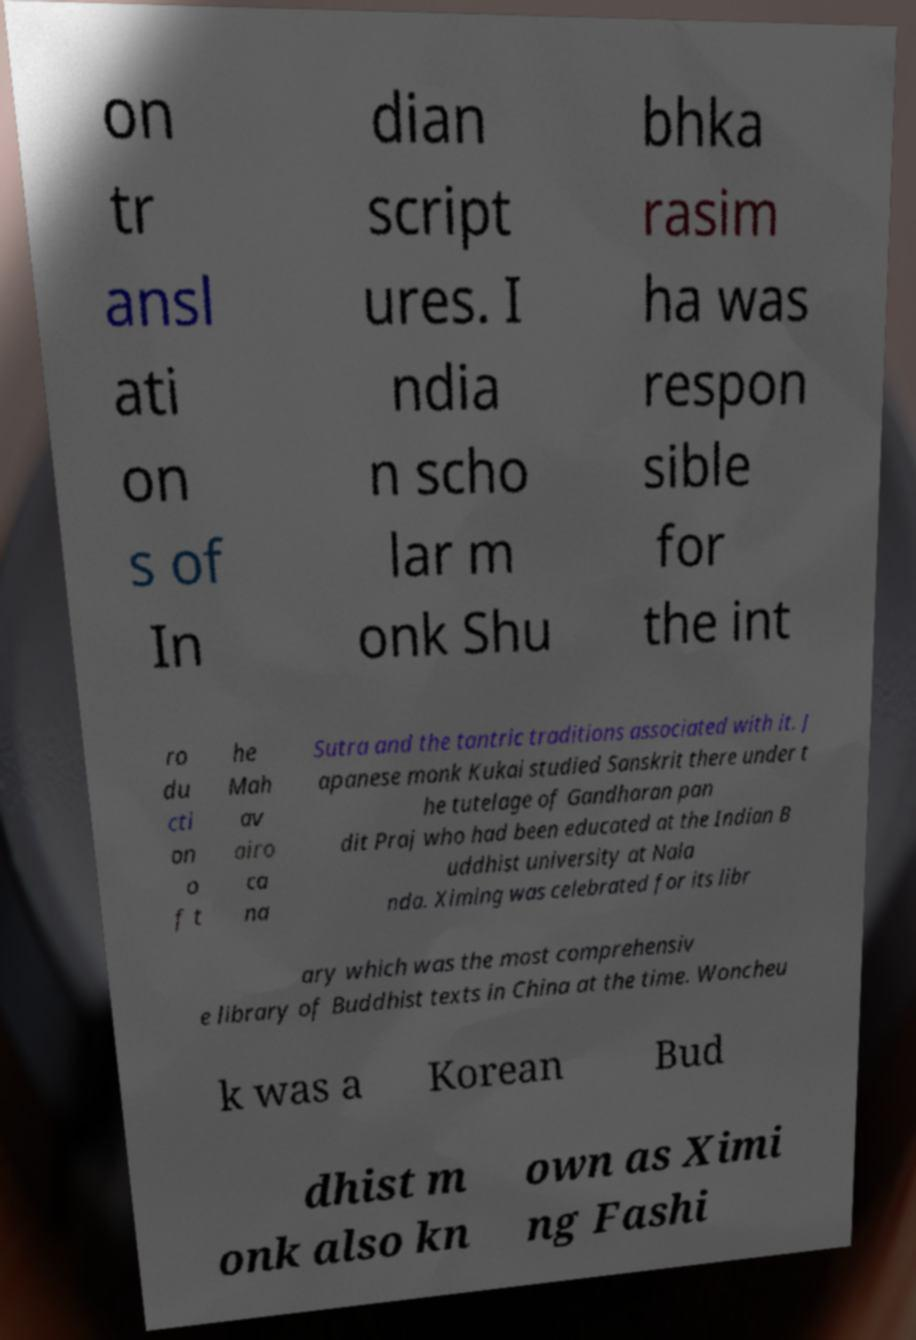What messages or text are displayed in this image? I need them in a readable, typed format. on tr ansl ati on s of In dian script ures. I ndia n scho lar m onk Shu bhka rasim ha was respon sible for the int ro du cti on o f t he Mah av airo ca na Sutra and the tantric traditions associated with it. J apanese monk Kukai studied Sanskrit there under t he tutelage of Gandharan pan dit Praj who had been educated at the Indian B uddhist university at Nala nda. Ximing was celebrated for its libr ary which was the most comprehensiv e library of Buddhist texts in China at the time. Woncheu k was a Korean Bud dhist m onk also kn own as Ximi ng Fashi 